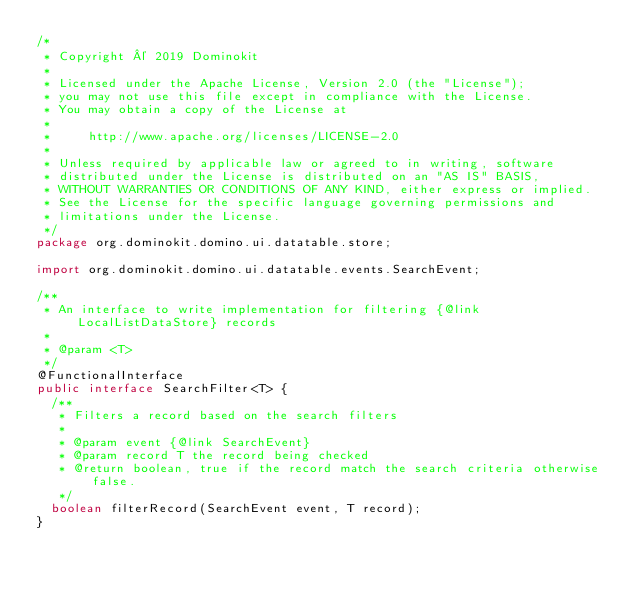Convert code to text. <code><loc_0><loc_0><loc_500><loc_500><_Java_>/*
 * Copyright © 2019 Dominokit
 *
 * Licensed under the Apache License, Version 2.0 (the "License");
 * you may not use this file except in compliance with the License.
 * You may obtain a copy of the License at
 *
 *     http://www.apache.org/licenses/LICENSE-2.0
 *
 * Unless required by applicable law or agreed to in writing, software
 * distributed under the License is distributed on an "AS IS" BASIS,
 * WITHOUT WARRANTIES OR CONDITIONS OF ANY KIND, either express or implied.
 * See the License for the specific language governing permissions and
 * limitations under the License.
 */
package org.dominokit.domino.ui.datatable.store;

import org.dominokit.domino.ui.datatable.events.SearchEvent;

/**
 * An interface to write implementation for filtering {@link LocalListDataStore} records
 *
 * @param <T>
 */
@FunctionalInterface
public interface SearchFilter<T> {
  /**
   * Filters a record based on the search filters
   *
   * @param event {@link SearchEvent}
   * @param record T the record being checked
   * @return boolean, true if the record match the search criteria otherwise false.
   */
  boolean filterRecord(SearchEvent event, T record);
}
</code> 